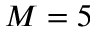Convert formula to latex. <formula><loc_0><loc_0><loc_500><loc_500>M = 5</formula> 